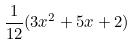Convert formula to latex. <formula><loc_0><loc_0><loc_500><loc_500>\frac { 1 } { 1 2 } ( 3 x ^ { 2 } + 5 x + 2 )</formula> 